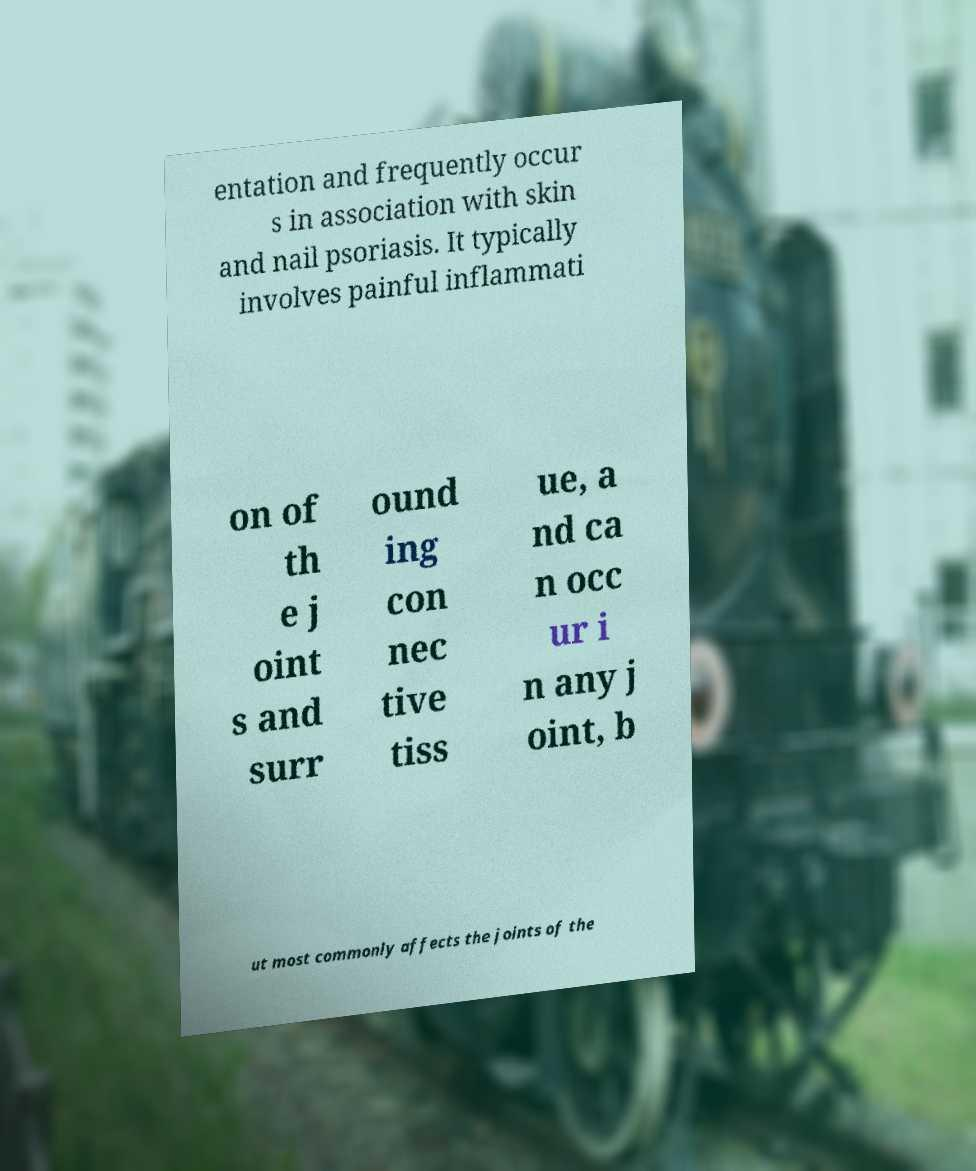Could you extract and type out the text from this image? entation and frequently occur s in association with skin and nail psoriasis. It typically involves painful inflammati on of th e j oint s and surr ound ing con nec tive tiss ue, a nd ca n occ ur i n any j oint, b ut most commonly affects the joints of the 